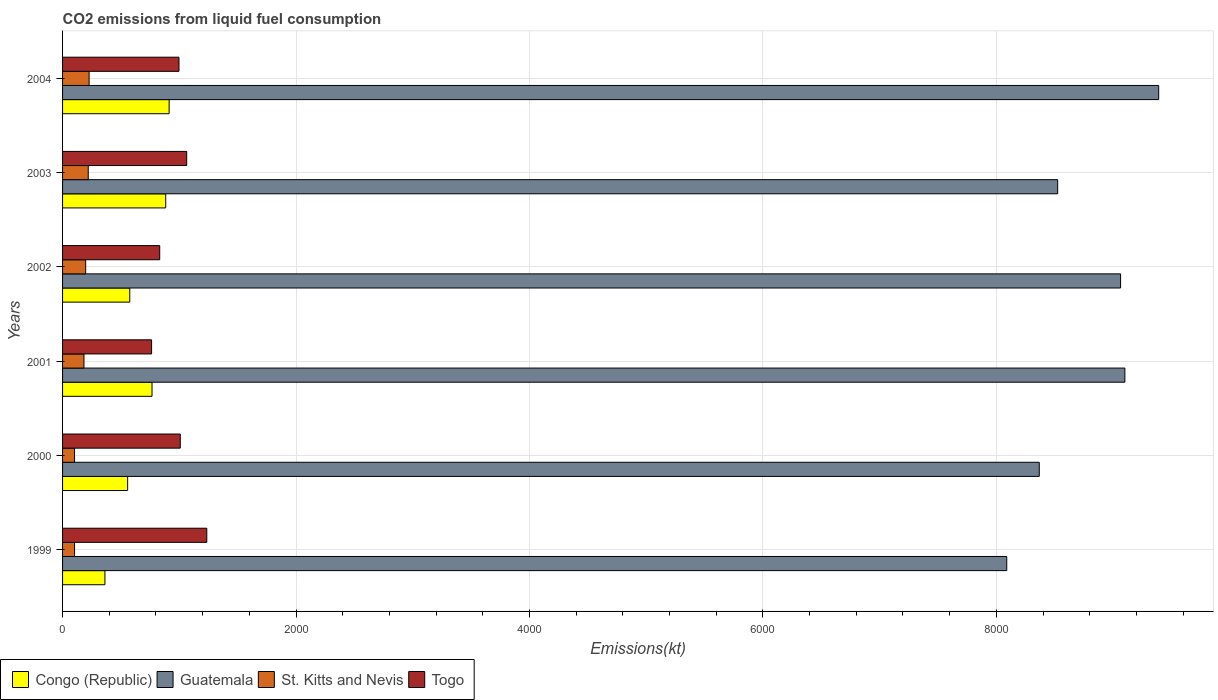How many different coloured bars are there?
Offer a terse response. 4. Are the number of bars per tick equal to the number of legend labels?
Offer a terse response. Yes. What is the amount of CO2 emitted in Guatemala in 2003?
Keep it short and to the point. 8525.77. Across all years, what is the maximum amount of CO2 emitted in St. Kitts and Nevis?
Make the answer very short. 227.35. Across all years, what is the minimum amount of CO2 emitted in Congo (Republic)?
Your answer should be very brief. 363.03. In which year was the amount of CO2 emitted in Congo (Republic) minimum?
Provide a short and direct response. 1999. What is the total amount of CO2 emitted in Togo in the graph?
Offer a terse response. 5900.2. What is the difference between the amount of CO2 emitted in St. Kitts and Nevis in 2001 and that in 2002?
Offer a terse response. -14.67. What is the difference between the amount of CO2 emitted in St. Kitts and Nevis in 2001 and the amount of CO2 emitted in Congo (Republic) in 1999?
Your answer should be compact. -179.68. What is the average amount of CO2 emitted in Togo per year?
Give a very brief answer. 983.37. In the year 2004, what is the difference between the amount of CO2 emitted in Congo (Republic) and amount of CO2 emitted in Guatemala?
Provide a succinct answer. -8478.1. What is the ratio of the amount of CO2 emitted in Guatemala in 2000 to that in 2003?
Offer a terse response. 0.98. What is the difference between the highest and the second highest amount of CO2 emitted in St. Kitts and Nevis?
Make the answer very short. 7.33. What is the difference between the highest and the lowest amount of CO2 emitted in Congo (Republic)?
Offer a very short reply. 550.05. In how many years, is the amount of CO2 emitted in Guatemala greater than the average amount of CO2 emitted in Guatemala taken over all years?
Your answer should be very brief. 3. What does the 2nd bar from the top in 1999 represents?
Provide a short and direct response. St. Kitts and Nevis. What does the 2nd bar from the bottom in 2001 represents?
Provide a succinct answer. Guatemala. How many bars are there?
Your answer should be very brief. 24. Are all the bars in the graph horizontal?
Make the answer very short. Yes. How many years are there in the graph?
Provide a short and direct response. 6. What is the difference between two consecutive major ticks on the X-axis?
Your answer should be very brief. 2000. Does the graph contain any zero values?
Your response must be concise. No. Where does the legend appear in the graph?
Keep it short and to the point. Bottom left. How many legend labels are there?
Make the answer very short. 4. What is the title of the graph?
Provide a succinct answer. CO2 emissions from liquid fuel consumption. What is the label or title of the X-axis?
Give a very brief answer. Emissions(kt). What is the label or title of the Y-axis?
Your response must be concise. Years. What is the Emissions(kt) in Congo (Republic) in 1999?
Your response must be concise. 363.03. What is the Emissions(kt) of Guatemala in 1999?
Offer a terse response. 8089.4. What is the Emissions(kt) in St. Kitts and Nevis in 1999?
Your answer should be very brief. 102.68. What is the Emissions(kt) in Togo in 1999?
Provide a short and direct response. 1235.78. What is the Emissions(kt) of Congo (Republic) in 2000?
Offer a very short reply. 557.38. What is the Emissions(kt) of Guatemala in 2000?
Ensure brevity in your answer.  8368.09. What is the Emissions(kt) in St. Kitts and Nevis in 2000?
Make the answer very short. 102.68. What is the Emissions(kt) of Togo in 2000?
Keep it short and to the point. 1008.42. What is the Emissions(kt) of Congo (Republic) in 2001?
Provide a succinct answer. 766.4. What is the Emissions(kt) in Guatemala in 2001?
Your answer should be very brief. 9101.49. What is the Emissions(kt) in St. Kitts and Nevis in 2001?
Give a very brief answer. 183.35. What is the Emissions(kt) of Togo in 2001?
Keep it short and to the point. 762.74. What is the Emissions(kt) of Congo (Republic) in 2002?
Provide a short and direct response. 575.72. What is the Emissions(kt) in Guatemala in 2002?
Offer a very short reply. 9064.82. What is the Emissions(kt) of St. Kitts and Nevis in 2002?
Make the answer very short. 198.02. What is the Emissions(kt) of Togo in 2002?
Provide a short and direct response. 832.41. What is the Emissions(kt) in Congo (Republic) in 2003?
Your answer should be very brief. 883.75. What is the Emissions(kt) in Guatemala in 2003?
Make the answer very short. 8525.77. What is the Emissions(kt) of St. Kitts and Nevis in 2003?
Give a very brief answer. 220.02. What is the Emissions(kt) of Togo in 2003?
Give a very brief answer. 1063.43. What is the Emissions(kt) of Congo (Republic) in 2004?
Provide a short and direct response. 913.08. What is the Emissions(kt) in Guatemala in 2004?
Ensure brevity in your answer.  9391.19. What is the Emissions(kt) of St. Kitts and Nevis in 2004?
Provide a succinct answer. 227.35. What is the Emissions(kt) in Togo in 2004?
Your answer should be very brief. 997.42. Across all years, what is the maximum Emissions(kt) of Congo (Republic)?
Keep it short and to the point. 913.08. Across all years, what is the maximum Emissions(kt) of Guatemala?
Keep it short and to the point. 9391.19. Across all years, what is the maximum Emissions(kt) in St. Kitts and Nevis?
Offer a terse response. 227.35. Across all years, what is the maximum Emissions(kt) of Togo?
Your answer should be very brief. 1235.78. Across all years, what is the minimum Emissions(kt) in Congo (Republic)?
Make the answer very short. 363.03. Across all years, what is the minimum Emissions(kt) of Guatemala?
Provide a succinct answer. 8089.4. Across all years, what is the minimum Emissions(kt) of St. Kitts and Nevis?
Your answer should be very brief. 102.68. Across all years, what is the minimum Emissions(kt) in Togo?
Offer a terse response. 762.74. What is the total Emissions(kt) in Congo (Republic) in the graph?
Offer a very short reply. 4059.37. What is the total Emissions(kt) of Guatemala in the graph?
Keep it short and to the point. 5.25e+04. What is the total Emissions(kt) in St. Kitts and Nevis in the graph?
Make the answer very short. 1034.09. What is the total Emissions(kt) of Togo in the graph?
Provide a succinct answer. 5900.2. What is the difference between the Emissions(kt) of Congo (Republic) in 1999 and that in 2000?
Your answer should be compact. -194.35. What is the difference between the Emissions(kt) in Guatemala in 1999 and that in 2000?
Your answer should be very brief. -278.69. What is the difference between the Emissions(kt) of St. Kitts and Nevis in 1999 and that in 2000?
Your response must be concise. 0. What is the difference between the Emissions(kt) in Togo in 1999 and that in 2000?
Ensure brevity in your answer.  227.35. What is the difference between the Emissions(kt) of Congo (Republic) in 1999 and that in 2001?
Provide a succinct answer. -403.37. What is the difference between the Emissions(kt) of Guatemala in 1999 and that in 2001?
Give a very brief answer. -1012.09. What is the difference between the Emissions(kt) of St. Kitts and Nevis in 1999 and that in 2001?
Ensure brevity in your answer.  -80.67. What is the difference between the Emissions(kt) of Togo in 1999 and that in 2001?
Provide a short and direct response. 473.04. What is the difference between the Emissions(kt) of Congo (Republic) in 1999 and that in 2002?
Keep it short and to the point. -212.69. What is the difference between the Emissions(kt) of Guatemala in 1999 and that in 2002?
Your response must be concise. -975.42. What is the difference between the Emissions(kt) of St. Kitts and Nevis in 1999 and that in 2002?
Offer a terse response. -95.34. What is the difference between the Emissions(kt) of Togo in 1999 and that in 2002?
Offer a very short reply. 403.37. What is the difference between the Emissions(kt) of Congo (Republic) in 1999 and that in 2003?
Offer a terse response. -520.71. What is the difference between the Emissions(kt) of Guatemala in 1999 and that in 2003?
Offer a terse response. -436.37. What is the difference between the Emissions(kt) of St. Kitts and Nevis in 1999 and that in 2003?
Ensure brevity in your answer.  -117.34. What is the difference between the Emissions(kt) of Togo in 1999 and that in 2003?
Offer a very short reply. 172.35. What is the difference between the Emissions(kt) of Congo (Republic) in 1999 and that in 2004?
Offer a very short reply. -550.05. What is the difference between the Emissions(kt) of Guatemala in 1999 and that in 2004?
Give a very brief answer. -1301.79. What is the difference between the Emissions(kt) in St. Kitts and Nevis in 1999 and that in 2004?
Your answer should be compact. -124.68. What is the difference between the Emissions(kt) in Togo in 1999 and that in 2004?
Ensure brevity in your answer.  238.35. What is the difference between the Emissions(kt) of Congo (Republic) in 2000 and that in 2001?
Offer a terse response. -209.02. What is the difference between the Emissions(kt) in Guatemala in 2000 and that in 2001?
Make the answer very short. -733.4. What is the difference between the Emissions(kt) in St. Kitts and Nevis in 2000 and that in 2001?
Give a very brief answer. -80.67. What is the difference between the Emissions(kt) in Togo in 2000 and that in 2001?
Your answer should be very brief. 245.69. What is the difference between the Emissions(kt) of Congo (Republic) in 2000 and that in 2002?
Offer a terse response. -18.34. What is the difference between the Emissions(kt) of Guatemala in 2000 and that in 2002?
Keep it short and to the point. -696.73. What is the difference between the Emissions(kt) in St. Kitts and Nevis in 2000 and that in 2002?
Your response must be concise. -95.34. What is the difference between the Emissions(kt) in Togo in 2000 and that in 2002?
Give a very brief answer. 176.02. What is the difference between the Emissions(kt) of Congo (Republic) in 2000 and that in 2003?
Your answer should be very brief. -326.36. What is the difference between the Emissions(kt) of Guatemala in 2000 and that in 2003?
Give a very brief answer. -157.68. What is the difference between the Emissions(kt) in St. Kitts and Nevis in 2000 and that in 2003?
Give a very brief answer. -117.34. What is the difference between the Emissions(kt) of Togo in 2000 and that in 2003?
Provide a short and direct response. -55.01. What is the difference between the Emissions(kt) of Congo (Republic) in 2000 and that in 2004?
Offer a very short reply. -355.7. What is the difference between the Emissions(kt) of Guatemala in 2000 and that in 2004?
Provide a short and direct response. -1023.09. What is the difference between the Emissions(kt) in St. Kitts and Nevis in 2000 and that in 2004?
Your answer should be very brief. -124.68. What is the difference between the Emissions(kt) of Togo in 2000 and that in 2004?
Provide a succinct answer. 11. What is the difference between the Emissions(kt) in Congo (Republic) in 2001 and that in 2002?
Offer a terse response. 190.68. What is the difference between the Emissions(kt) of Guatemala in 2001 and that in 2002?
Offer a terse response. 36.67. What is the difference between the Emissions(kt) in St. Kitts and Nevis in 2001 and that in 2002?
Provide a succinct answer. -14.67. What is the difference between the Emissions(kt) in Togo in 2001 and that in 2002?
Provide a short and direct response. -69.67. What is the difference between the Emissions(kt) in Congo (Republic) in 2001 and that in 2003?
Provide a short and direct response. -117.34. What is the difference between the Emissions(kt) in Guatemala in 2001 and that in 2003?
Provide a succinct answer. 575.72. What is the difference between the Emissions(kt) in St. Kitts and Nevis in 2001 and that in 2003?
Make the answer very short. -36.67. What is the difference between the Emissions(kt) of Togo in 2001 and that in 2003?
Ensure brevity in your answer.  -300.69. What is the difference between the Emissions(kt) in Congo (Republic) in 2001 and that in 2004?
Keep it short and to the point. -146.68. What is the difference between the Emissions(kt) of Guatemala in 2001 and that in 2004?
Offer a terse response. -289.69. What is the difference between the Emissions(kt) in St. Kitts and Nevis in 2001 and that in 2004?
Provide a short and direct response. -44. What is the difference between the Emissions(kt) of Togo in 2001 and that in 2004?
Your answer should be compact. -234.69. What is the difference between the Emissions(kt) of Congo (Republic) in 2002 and that in 2003?
Ensure brevity in your answer.  -308.03. What is the difference between the Emissions(kt) of Guatemala in 2002 and that in 2003?
Keep it short and to the point. 539.05. What is the difference between the Emissions(kt) in St. Kitts and Nevis in 2002 and that in 2003?
Ensure brevity in your answer.  -22. What is the difference between the Emissions(kt) of Togo in 2002 and that in 2003?
Provide a short and direct response. -231.02. What is the difference between the Emissions(kt) of Congo (Republic) in 2002 and that in 2004?
Ensure brevity in your answer.  -337.36. What is the difference between the Emissions(kt) in Guatemala in 2002 and that in 2004?
Ensure brevity in your answer.  -326.36. What is the difference between the Emissions(kt) in St. Kitts and Nevis in 2002 and that in 2004?
Make the answer very short. -29.34. What is the difference between the Emissions(kt) of Togo in 2002 and that in 2004?
Make the answer very short. -165.01. What is the difference between the Emissions(kt) in Congo (Republic) in 2003 and that in 2004?
Ensure brevity in your answer.  -29.34. What is the difference between the Emissions(kt) in Guatemala in 2003 and that in 2004?
Provide a succinct answer. -865.41. What is the difference between the Emissions(kt) of St. Kitts and Nevis in 2003 and that in 2004?
Your response must be concise. -7.33. What is the difference between the Emissions(kt) of Togo in 2003 and that in 2004?
Your response must be concise. 66.01. What is the difference between the Emissions(kt) of Congo (Republic) in 1999 and the Emissions(kt) of Guatemala in 2000?
Offer a terse response. -8005.06. What is the difference between the Emissions(kt) of Congo (Republic) in 1999 and the Emissions(kt) of St. Kitts and Nevis in 2000?
Keep it short and to the point. 260.36. What is the difference between the Emissions(kt) in Congo (Republic) in 1999 and the Emissions(kt) in Togo in 2000?
Your answer should be very brief. -645.39. What is the difference between the Emissions(kt) of Guatemala in 1999 and the Emissions(kt) of St. Kitts and Nevis in 2000?
Provide a short and direct response. 7986.73. What is the difference between the Emissions(kt) in Guatemala in 1999 and the Emissions(kt) in Togo in 2000?
Ensure brevity in your answer.  7080.98. What is the difference between the Emissions(kt) in St. Kitts and Nevis in 1999 and the Emissions(kt) in Togo in 2000?
Ensure brevity in your answer.  -905.75. What is the difference between the Emissions(kt) in Congo (Republic) in 1999 and the Emissions(kt) in Guatemala in 2001?
Provide a succinct answer. -8738.46. What is the difference between the Emissions(kt) in Congo (Republic) in 1999 and the Emissions(kt) in St. Kitts and Nevis in 2001?
Your response must be concise. 179.68. What is the difference between the Emissions(kt) of Congo (Republic) in 1999 and the Emissions(kt) of Togo in 2001?
Offer a terse response. -399.7. What is the difference between the Emissions(kt) in Guatemala in 1999 and the Emissions(kt) in St. Kitts and Nevis in 2001?
Make the answer very short. 7906.05. What is the difference between the Emissions(kt) of Guatemala in 1999 and the Emissions(kt) of Togo in 2001?
Keep it short and to the point. 7326.67. What is the difference between the Emissions(kt) in St. Kitts and Nevis in 1999 and the Emissions(kt) in Togo in 2001?
Offer a terse response. -660.06. What is the difference between the Emissions(kt) in Congo (Republic) in 1999 and the Emissions(kt) in Guatemala in 2002?
Give a very brief answer. -8701.79. What is the difference between the Emissions(kt) in Congo (Republic) in 1999 and the Emissions(kt) in St. Kitts and Nevis in 2002?
Your answer should be very brief. 165.01. What is the difference between the Emissions(kt) of Congo (Republic) in 1999 and the Emissions(kt) of Togo in 2002?
Offer a very short reply. -469.38. What is the difference between the Emissions(kt) in Guatemala in 1999 and the Emissions(kt) in St. Kitts and Nevis in 2002?
Offer a very short reply. 7891.38. What is the difference between the Emissions(kt) in Guatemala in 1999 and the Emissions(kt) in Togo in 2002?
Give a very brief answer. 7256.99. What is the difference between the Emissions(kt) of St. Kitts and Nevis in 1999 and the Emissions(kt) of Togo in 2002?
Offer a very short reply. -729.73. What is the difference between the Emissions(kt) of Congo (Republic) in 1999 and the Emissions(kt) of Guatemala in 2003?
Make the answer very short. -8162.74. What is the difference between the Emissions(kt) in Congo (Republic) in 1999 and the Emissions(kt) in St. Kitts and Nevis in 2003?
Provide a succinct answer. 143.01. What is the difference between the Emissions(kt) of Congo (Republic) in 1999 and the Emissions(kt) of Togo in 2003?
Offer a terse response. -700.4. What is the difference between the Emissions(kt) in Guatemala in 1999 and the Emissions(kt) in St. Kitts and Nevis in 2003?
Provide a succinct answer. 7869.38. What is the difference between the Emissions(kt) of Guatemala in 1999 and the Emissions(kt) of Togo in 2003?
Your answer should be very brief. 7025.97. What is the difference between the Emissions(kt) in St. Kitts and Nevis in 1999 and the Emissions(kt) in Togo in 2003?
Your answer should be compact. -960.75. What is the difference between the Emissions(kt) of Congo (Republic) in 1999 and the Emissions(kt) of Guatemala in 2004?
Provide a short and direct response. -9028.15. What is the difference between the Emissions(kt) in Congo (Republic) in 1999 and the Emissions(kt) in St. Kitts and Nevis in 2004?
Your answer should be compact. 135.68. What is the difference between the Emissions(kt) in Congo (Republic) in 1999 and the Emissions(kt) in Togo in 2004?
Give a very brief answer. -634.39. What is the difference between the Emissions(kt) in Guatemala in 1999 and the Emissions(kt) in St. Kitts and Nevis in 2004?
Offer a very short reply. 7862.05. What is the difference between the Emissions(kt) in Guatemala in 1999 and the Emissions(kt) in Togo in 2004?
Ensure brevity in your answer.  7091.98. What is the difference between the Emissions(kt) of St. Kitts and Nevis in 1999 and the Emissions(kt) of Togo in 2004?
Ensure brevity in your answer.  -894.75. What is the difference between the Emissions(kt) in Congo (Republic) in 2000 and the Emissions(kt) in Guatemala in 2001?
Give a very brief answer. -8544.11. What is the difference between the Emissions(kt) of Congo (Republic) in 2000 and the Emissions(kt) of St. Kitts and Nevis in 2001?
Provide a short and direct response. 374.03. What is the difference between the Emissions(kt) of Congo (Republic) in 2000 and the Emissions(kt) of Togo in 2001?
Offer a very short reply. -205.35. What is the difference between the Emissions(kt) in Guatemala in 2000 and the Emissions(kt) in St. Kitts and Nevis in 2001?
Offer a very short reply. 8184.74. What is the difference between the Emissions(kt) in Guatemala in 2000 and the Emissions(kt) in Togo in 2001?
Offer a terse response. 7605.36. What is the difference between the Emissions(kt) of St. Kitts and Nevis in 2000 and the Emissions(kt) of Togo in 2001?
Your answer should be compact. -660.06. What is the difference between the Emissions(kt) of Congo (Republic) in 2000 and the Emissions(kt) of Guatemala in 2002?
Give a very brief answer. -8507.44. What is the difference between the Emissions(kt) of Congo (Republic) in 2000 and the Emissions(kt) of St. Kitts and Nevis in 2002?
Your answer should be compact. 359.37. What is the difference between the Emissions(kt) of Congo (Republic) in 2000 and the Emissions(kt) of Togo in 2002?
Provide a succinct answer. -275.02. What is the difference between the Emissions(kt) of Guatemala in 2000 and the Emissions(kt) of St. Kitts and Nevis in 2002?
Offer a terse response. 8170.08. What is the difference between the Emissions(kt) of Guatemala in 2000 and the Emissions(kt) of Togo in 2002?
Give a very brief answer. 7535.69. What is the difference between the Emissions(kt) of St. Kitts and Nevis in 2000 and the Emissions(kt) of Togo in 2002?
Offer a terse response. -729.73. What is the difference between the Emissions(kt) in Congo (Republic) in 2000 and the Emissions(kt) in Guatemala in 2003?
Provide a succinct answer. -7968.39. What is the difference between the Emissions(kt) of Congo (Republic) in 2000 and the Emissions(kt) of St. Kitts and Nevis in 2003?
Make the answer very short. 337.36. What is the difference between the Emissions(kt) in Congo (Republic) in 2000 and the Emissions(kt) in Togo in 2003?
Give a very brief answer. -506.05. What is the difference between the Emissions(kt) in Guatemala in 2000 and the Emissions(kt) in St. Kitts and Nevis in 2003?
Offer a terse response. 8148.07. What is the difference between the Emissions(kt) in Guatemala in 2000 and the Emissions(kt) in Togo in 2003?
Your answer should be very brief. 7304.66. What is the difference between the Emissions(kt) in St. Kitts and Nevis in 2000 and the Emissions(kt) in Togo in 2003?
Your answer should be very brief. -960.75. What is the difference between the Emissions(kt) in Congo (Republic) in 2000 and the Emissions(kt) in Guatemala in 2004?
Give a very brief answer. -8833.8. What is the difference between the Emissions(kt) of Congo (Republic) in 2000 and the Emissions(kt) of St. Kitts and Nevis in 2004?
Your answer should be very brief. 330.03. What is the difference between the Emissions(kt) in Congo (Republic) in 2000 and the Emissions(kt) in Togo in 2004?
Give a very brief answer. -440.04. What is the difference between the Emissions(kt) in Guatemala in 2000 and the Emissions(kt) in St. Kitts and Nevis in 2004?
Your response must be concise. 8140.74. What is the difference between the Emissions(kt) in Guatemala in 2000 and the Emissions(kt) in Togo in 2004?
Keep it short and to the point. 7370.67. What is the difference between the Emissions(kt) of St. Kitts and Nevis in 2000 and the Emissions(kt) of Togo in 2004?
Your response must be concise. -894.75. What is the difference between the Emissions(kt) of Congo (Republic) in 2001 and the Emissions(kt) of Guatemala in 2002?
Provide a short and direct response. -8298.42. What is the difference between the Emissions(kt) in Congo (Republic) in 2001 and the Emissions(kt) in St. Kitts and Nevis in 2002?
Ensure brevity in your answer.  568.38. What is the difference between the Emissions(kt) of Congo (Republic) in 2001 and the Emissions(kt) of Togo in 2002?
Provide a short and direct response. -66.01. What is the difference between the Emissions(kt) of Guatemala in 2001 and the Emissions(kt) of St. Kitts and Nevis in 2002?
Keep it short and to the point. 8903.48. What is the difference between the Emissions(kt) of Guatemala in 2001 and the Emissions(kt) of Togo in 2002?
Make the answer very short. 8269.08. What is the difference between the Emissions(kt) of St. Kitts and Nevis in 2001 and the Emissions(kt) of Togo in 2002?
Ensure brevity in your answer.  -649.06. What is the difference between the Emissions(kt) in Congo (Republic) in 2001 and the Emissions(kt) in Guatemala in 2003?
Offer a terse response. -7759.37. What is the difference between the Emissions(kt) of Congo (Republic) in 2001 and the Emissions(kt) of St. Kitts and Nevis in 2003?
Offer a very short reply. 546.38. What is the difference between the Emissions(kt) of Congo (Republic) in 2001 and the Emissions(kt) of Togo in 2003?
Keep it short and to the point. -297.03. What is the difference between the Emissions(kt) of Guatemala in 2001 and the Emissions(kt) of St. Kitts and Nevis in 2003?
Make the answer very short. 8881.47. What is the difference between the Emissions(kt) in Guatemala in 2001 and the Emissions(kt) in Togo in 2003?
Make the answer very short. 8038.06. What is the difference between the Emissions(kt) of St. Kitts and Nevis in 2001 and the Emissions(kt) of Togo in 2003?
Give a very brief answer. -880.08. What is the difference between the Emissions(kt) of Congo (Republic) in 2001 and the Emissions(kt) of Guatemala in 2004?
Offer a terse response. -8624.78. What is the difference between the Emissions(kt) in Congo (Republic) in 2001 and the Emissions(kt) in St. Kitts and Nevis in 2004?
Ensure brevity in your answer.  539.05. What is the difference between the Emissions(kt) in Congo (Republic) in 2001 and the Emissions(kt) in Togo in 2004?
Ensure brevity in your answer.  -231.02. What is the difference between the Emissions(kt) in Guatemala in 2001 and the Emissions(kt) in St. Kitts and Nevis in 2004?
Offer a very short reply. 8874.14. What is the difference between the Emissions(kt) in Guatemala in 2001 and the Emissions(kt) in Togo in 2004?
Ensure brevity in your answer.  8104.07. What is the difference between the Emissions(kt) of St. Kitts and Nevis in 2001 and the Emissions(kt) of Togo in 2004?
Make the answer very short. -814.07. What is the difference between the Emissions(kt) in Congo (Republic) in 2002 and the Emissions(kt) in Guatemala in 2003?
Ensure brevity in your answer.  -7950.06. What is the difference between the Emissions(kt) of Congo (Republic) in 2002 and the Emissions(kt) of St. Kitts and Nevis in 2003?
Provide a succinct answer. 355.7. What is the difference between the Emissions(kt) of Congo (Republic) in 2002 and the Emissions(kt) of Togo in 2003?
Keep it short and to the point. -487.71. What is the difference between the Emissions(kt) in Guatemala in 2002 and the Emissions(kt) in St. Kitts and Nevis in 2003?
Provide a succinct answer. 8844.8. What is the difference between the Emissions(kt) in Guatemala in 2002 and the Emissions(kt) in Togo in 2003?
Your response must be concise. 8001.39. What is the difference between the Emissions(kt) in St. Kitts and Nevis in 2002 and the Emissions(kt) in Togo in 2003?
Your response must be concise. -865.41. What is the difference between the Emissions(kt) in Congo (Republic) in 2002 and the Emissions(kt) in Guatemala in 2004?
Give a very brief answer. -8815.47. What is the difference between the Emissions(kt) in Congo (Republic) in 2002 and the Emissions(kt) in St. Kitts and Nevis in 2004?
Your response must be concise. 348.37. What is the difference between the Emissions(kt) in Congo (Republic) in 2002 and the Emissions(kt) in Togo in 2004?
Keep it short and to the point. -421.7. What is the difference between the Emissions(kt) in Guatemala in 2002 and the Emissions(kt) in St. Kitts and Nevis in 2004?
Offer a very short reply. 8837.47. What is the difference between the Emissions(kt) in Guatemala in 2002 and the Emissions(kt) in Togo in 2004?
Ensure brevity in your answer.  8067.4. What is the difference between the Emissions(kt) in St. Kitts and Nevis in 2002 and the Emissions(kt) in Togo in 2004?
Give a very brief answer. -799.41. What is the difference between the Emissions(kt) of Congo (Republic) in 2003 and the Emissions(kt) of Guatemala in 2004?
Ensure brevity in your answer.  -8507.44. What is the difference between the Emissions(kt) of Congo (Republic) in 2003 and the Emissions(kt) of St. Kitts and Nevis in 2004?
Your response must be concise. 656.39. What is the difference between the Emissions(kt) of Congo (Republic) in 2003 and the Emissions(kt) of Togo in 2004?
Your answer should be very brief. -113.68. What is the difference between the Emissions(kt) in Guatemala in 2003 and the Emissions(kt) in St. Kitts and Nevis in 2004?
Make the answer very short. 8298.42. What is the difference between the Emissions(kt) in Guatemala in 2003 and the Emissions(kt) in Togo in 2004?
Your answer should be very brief. 7528.35. What is the difference between the Emissions(kt) of St. Kitts and Nevis in 2003 and the Emissions(kt) of Togo in 2004?
Offer a terse response. -777.4. What is the average Emissions(kt) of Congo (Republic) per year?
Ensure brevity in your answer.  676.56. What is the average Emissions(kt) in Guatemala per year?
Provide a short and direct response. 8756.8. What is the average Emissions(kt) in St. Kitts and Nevis per year?
Your answer should be compact. 172.35. What is the average Emissions(kt) in Togo per year?
Provide a succinct answer. 983.37. In the year 1999, what is the difference between the Emissions(kt) in Congo (Republic) and Emissions(kt) in Guatemala?
Your response must be concise. -7726.37. In the year 1999, what is the difference between the Emissions(kt) of Congo (Republic) and Emissions(kt) of St. Kitts and Nevis?
Make the answer very short. 260.36. In the year 1999, what is the difference between the Emissions(kt) of Congo (Republic) and Emissions(kt) of Togo?
Provide a short and direct response. -872.75. In the year 1999, what is the difference between the Emissions(kt) in Guatemala and Emissions(kt) in St. Kitts and Nevis?
Make the answer very short. 7986.73. In the year 1999, what is the difference between the Emissions(kt) in Guatemala and Emissions(kt) in Togo?
Your response must be concise. 6853.62. In the year 1999, what is the difference between the Emissions(kt) in St. Kitts and Nevis and Emissions(kt) in Togo?
Your answer should be very brief. -1133.1. In the year 2000, what is the difference between the Emissions(kt) in Congo (Republic) and Emissions(kt) in Guatemala?
Provide a short and direct response. -7810.71. In the year 2000, what is the difference between the Emissions(kt) in Congo (Republic) and Emissions(kt) in St. Kitts and Nevis?
Your answer should be compact. 454.71. In the year 2000, what is the difference between the Emissions(kt) in Congo (Republic) and Emissions(kt) in Togo?
Your answer should be compact. -451.04. In the year 2000, what is the difference between the Emissions(kt) in Guatemala and Emissions(kt) in St. Kitts and Nevis?
Offer a very short reply. 8265.42. In the year 2000, what is the difference between the Emissions(kt) in Guatemala and Emissions(kt) in Togo?
Keep it short and to the point. 7359.67. In the year 2000, what is the difference between the Emissions(kt) in St. Kitts and Nevis and Emissions(kt) in Togo?
Your answer should be compact. -905.75. In the year 2001, what is the difference between the Emissions(kt) of Congo (Republic) and Emissions(kt) of Guatemala?
Make the answer very short. -8335.09. In the year 2001, what is the difference between the Emissions(kt) in Congo (Republic) and Emissions(kt) in St. Kitts and Nevis?
Give a very brief answer. 583.05. In the year 2001, what is the difference between the Emissions(kt) in Congo (Republic) and Emissions(kt) in Togo?
Offer a very short reply. 3.67. In the year 2001, what is the difference between the Emissions(kt) in Guatemala and Emissions(kt) in St. Kitts and Nevis?
Your response must be concise. 8918.14. In the year 2001, what is the difference between the Emissions(kt) of Guatemala and Emissions(kt) of Togo?
Offer a very short reply. 8338.76. In the year 2001, what is the difference between the Emissions(kt) in St. Kitts and Nevis and Emissions(kt) in Togo?
Make the answer very short. -579.39. In the year 2002, what is the difference between the Emissions(kt) of Congo (Republic) and Emissions(kt) of Guatemala?
Provide a short and direct response. -8489.1. In the year 2002, what is the difference between the Emissions(kt) in Congo (Republic) and Emissions(kt) in St. Kitts and Nevis?
Your answer should be compact. 377.7. In the year 2002, what is the difference between the Emissions(kt) in Congo (Republic) and Emissions(kt) in Togo?
Your answer should be very brief. -256.69. In the year 2002, what is the difference between the Emissions(kt) in Guatemala and Emissions(kt) in St. Kitts and Nevis?
Provide a succinct answer. 8866.81. In the year 2002, what is the difference between the Emissions(kt) of Guatemala and Emissions(kt) of Togo?
Make the answer very short. 8232.42. In the year 2002, what is the difference between the Emissions(kt) of St. Kitts and Nevis and Emissions(kt) of Togo?
Your answer should be compact. -634.39. In the year 2003, what is the difference between the Emissions(kt) of Congo (Republic) and Emissions(kt) of Guatemala?
Offer a terse response. -7642.03. In the year 2003, what is the difference between the Emissions(kt) in Congo (Republic) and Emissions(kt) in St. Kitts and Nevis?
Your response must be concise. 663.73. In the year 2003, what is the difference between the Emissions(kt) of Congo (Republic) and Emissions(kt) of Togo?
Ensure brevity in your answer.  -179.68. In the year 2003, what is the difference between the Emissions(kt) in Guatemala and Emissions(kt) in St. Kitts and Nevis?
Keep it short and to the point. 8305.75. In the year 2003, what is the difference between the Emissions(kt) in Guatemala and Emissions(kt) in Togo?
Give a very brief answer. 7462.35. In the year 2003, what is the difference between the Emissions(kt) in St. Kitts and Nevis and Emissions(kt) in Togo?
Ensure brevity in your answer.  -843.41. In the year 2004, what is the difference between the Emissions(kt) in Congo (Republic) and Emissions(kt) in Guatemala?
Keep it short and to the point. -8478.1. In the year 2004, what is the difference between the Emissions(kt) of Congo (Republic) and Emissions(kt) of St. Kitts and Nevis?
Keep it short and to the point. 685.73. In the year 2004, what is the difference between the Emissions(kt) in Congo (Republic) and Emissions(kt) in Togo?
Your answer should be compact. -84.34. In the year 2004, what is the difference between the Emissions(kt) in Guatemala and Emissions(kt) in St. Kitts and Nevis?
Make the answer very short. 9163.83. In the year 2004, what is the difference between the Emissions(kt) in Guatemala and Emissions(kt) in Togo?
Your response must be concise. 8393.76. In the year 2004, what is the difference between the Emissions(kt) of St. Kitts and Nevis and Emissions(kt) of Togo?
Provide a short and direct response. -770.07. What is the ratio of the Emissions(kt) in Congo (Republic) in 1999 to that in 2000?
Provide a succinct answer. 0.65. What is the ratio of the Emissions(kt) of Guatemala in 1999 to that in 2000?
Make the answer very short. 0.97. What is the ratio of the Emissions(kt) of St. Kitts and Nevis in 1999 to that in 2000?
Your response must be concise. 1. What is the ratio of the Emissions(kt) of Togo in 1999 to that in 2000?
Provide a short and direct response. 1.23. What is the ratio of the Emissions(kt) in Congo (Republic) in 1999 to that in 2001?
Your response must be concise. 0.47. What is the ratio of the Emissions(kt) of Guatemala in 1999 to that in 2001?
Ensure brevity in your answer.  0.89. What is the ratio of the Emissions(kt) of St. Kitts and Nevis in 1999 to that in 2001?
Your answer should be very brief. 0.56. What is the ratio of the Emissions(kt) in Togo in 1999 to that in 2001?
Offer a very short reply. 1.62. What is the ratio of the Emissions(kt) of Congo (Republic) in 1999 to that in 2002?
Provide a short and direct response. 0.63. What is the ratio of the Emissions(kt) of Guatemala in 1999 to that in 2002?
Your response must be concise. 0.89. What is the ratio of the Emissions(kt) of St. Kitts and Nevis in 1999 to that in 2002?
Offer a very short reply. 0.52. What is the ratio of the Emissions(kt) in Togo in 1999 to that in 2002?
Your answer should be very brief. 1.48. What is the ratio of the Emissions(kt) in Congo (Republic) in 1999 to that in 2003?
Ensure brevity in your answer.  0.41. What is the ratio of the Emissions(kt) in Guatemala in 1999 to that in 2003?
Offer a very short reply. 0.95. What is the ratio of the Emissions(kt) in St. Kitts and Nevis in 1999 to that in 2003?
Keep it short and to the point. 0.47. What is the ratio of the Emissions(kt) in Togo in 1999 to that in 2003?
Offer a very short reply. 1.16. What is the ratio of the Emissions(kt) in Congo (Republic) in 1999 to that in 2004?
Keep it short and to the point. 0.4. What is the ratio of the Emissions(kt) in Guatemala in 1999 to that in 2004?
Make the answer very short. 0.86. What is the ratio of the Emissions(kt) in St. Kitts and Nevis in 1999 to that in 2004?
Give a very brief answer. 0.45. What is the ratio of the Emissions(kt) of Togo in 1999 to that in 2004?
Provide a succinct answer. 1.24. What is the ratio of the Emissions(kt) of Congo (Republic) in 2000 to that in 2001?
Provide a succinct answer. 0.73. What is the ratio of the Emissions(kt) in Guatemala in 2000 to that in 2001?
Keep it short and to the point. 0.92. What is the ratio of the Emissions(kt) of St. Kitts and Nevis in 2000 to that in 2001?
Offer a very short reply. 0.56. What is the ratio of the Emissions(kt) of Togo in 2000 to that in 2001?
Your response must be concise. 1.32. What is the ratio of the Emissions(kt) in Congo (Republic) in 2000 to that in 2002?
Keep it short and to the point. 0.97. What is the ratio of the Emissions(kt) of St. Kitts and Nevis in 2000 to that in 2002?
Give a very brief answer. 0.52. What is the ratio of the Emissions(kt) in Togo in 2000 to that in 2002?
Provide a short and direct response. 1.21. What is the ratio of the Emissions(kt) in Congo (Republic) in 2000 to that in 2003?
Your response must be concise. 0.63. What is the ratio of the Emissions(kt) in Guatemala in 2000 to that in 2003?
Offer a very short reply. 0.98. What is the ratio of the Emissions(kt) in St. Kitts and Nevis in 2000 to that in 2003?
Provide a succinct answer. 0.47. What is the ratio of the Emissions(kt) in Togo in 2000 to that in 2003?
Your response must be concise. 0.95. What is the ratio of the Emissions(kt) of Congo (Republic) in 2000 to that in 2004?
Your answer should be compact. 0.61. What is the ratio of the Emissions(kt) in Guatemala in 2000 to that in 2004?
Make the answer very short. 0.89. What is the ratio of the Emissions(kt) in St. Kitts and Nevis in 2000 to that in 2004?
Provide a short and direct response. 0.45. What is the ratio of the Emissions(kt) in Togo in 2000 to that in 2004?
Your response must be concise. 1.01. What is the ratio of the Emissions(kt) in Congo (Republic) in 2001 to that in 2002?
Provide a succinct answer. 1.33. What is the ratio of the Emissions(kt) in St. Kitts and Nevis in 2001 to that in 2002?
Make the answer very short. 0.93. What is the ratio of the Emissions(kt) of Togo in 2001 to that in 2002?
Ensure brevity in your answer.  0.92. What is the ratio of the Emissions(kt) of Congo (Republic) in 2001 to that in 2003?
Give a very brief answer. 0.87. What is the ratio of the Emissions(kt) of Guatemala in 2001 to that in 2003?
Provide a short and direct response. 1.07. What is the ratio of the Emissions(kt) of Togo in 2001 to that in 2003?
Provide a succinct answer. 0.72. What is the ratio of the Emissions(kt) in Congo (Republic) in 2001 to that in 2004?
Provide a succinct answer. 0.84. What is the ratio of the Emissions(kt) in Guatemala in 2001 to that in 2004?
Ensure brevity in your answer.  0.97. What is the ratio of the Emissions(kt) in St. Kitts and Nevis in 2001 to that in 2004?
Offer a very short reply. 0.81. What is the ratio of the Emissions(kt) in Togo in 2001 to that in 2004?
Provide a succinct answer. 0.76. What is the ratio of the Emissions(kt) in Congo (Republic) in 2002 to that in 2003?
Provide a short and direct response. 0.65. What is the ratio of the Emissions(kt) in Guatemala in 2002 to that in 2003?
Provide a short and direct response. 1.06. What is the ratio of the Emissions(kt) of St. Kitts and Nevis in 2002 to that in 2003?
Keep it short and to the point. 0.9. What is the ratio of the Emissions(kt) of Togo in 2002 to that in 2003?
Your answer should be very brief. 0.78. What is the ratio of the Emissions(kt) of Congo (Republic) in 2002 to that in 2004?
Your answer should be very brief. 0.63. What is the ratio of the Emissions(kt) in Guatemala in 2002 to that in 2004?
Your response must be concise. 0.97. What is the ratio of the Emissions(kt) of St. Kitts and Nevis in 2002 to that in 2004?
Keep it short and to the point. 0.87. What is the ratio of the Emissions(kt) in Togo in 2002 to that in 2004?
Provide a short and direct response. 0.83. What is the ratio of the Emissions(kt) of Congo (Republic) in 2003 to that in 2004?
Offer a terse response. 0.97. What is the ratio of the Emissions(kt) of Guatemala in 2003 to that in 2004?
Provide a succinct answer. 0.91. What is the ratio of the Emissions(kt) of Togo in 2003 to that in 2004?
Ensure brevity in your answer.  1.07. What is the difference between the highest and the second highest Emissions(kt) in Congo (Republic)?
Your answer should be very brief. 29.34. What is the difference between the highest and the second highest Emissions(kt) of Guatemala?
Your response must be concise. 289.69. What is the difference between the highest and the second highest Emissions(kt) in St. Kitts and Nevis?
Your response must be concise. 7.33. What is the difference between the highest and the second highest Emissions(kt) in Togo?
Provide a succinct answer. 172.35. What is the difference between the highest and the lowest Emissions(kt) in Congo (Republic)?
Your answer should be very brief. 550.05. What is the difference between the highest and the lowest Emissions(kt) of Guatemala?
Give a very brief answer. 1301.79. What is the difference between the highest and the lowest Emissions(kt) in St. Kitts and Nevis?
Your answer should be very brief. 124.68. What is the difference between the highest and the lowest Emissions(kt) in Togo?
Offer a terse response. 473.04. 